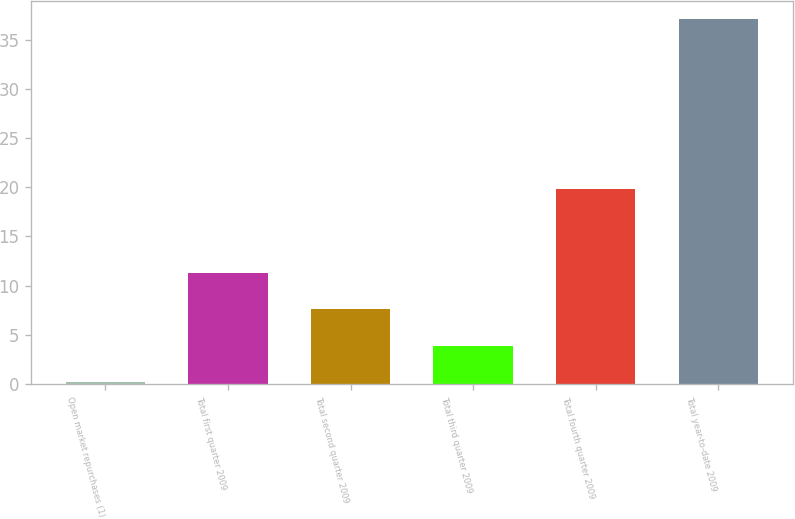Convert chart to OTSL. <chart><loc_0><loc_0><loc_500><loc_500><bar_chart><fcel>Open market repurchases (1)<fcel>Total first quarter 2009<fcel>Total second quarter 2009<fcel>Total third quarter 2009<fcel>Total fourth quarter 2009<fcel>Total year-to-date 2009<nl><fcel>0.2<fcel>11.27<fcel>7.58<fcel>3.89<fcel>19.8<fcel>37.1<nl></chart> 